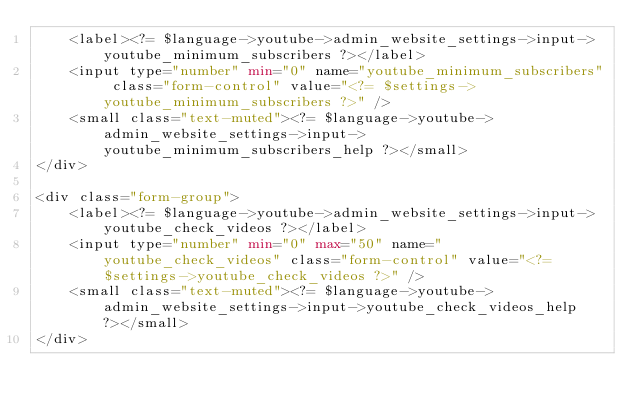<code> <loc_0><loc_0><loc_500><loc_500><_PHP_>    <label><?= $language->youtube->admin_website_settings->input->youtube_minimum_subscribers ?></label>
    <input type="number" min="0" name="youtube_minimum_subscribers" class="form-control" value="<?= $settings->youtube_minimum_subscribers ?>" />
    <small class="text-muted"><?= $language->youtube->admin_website_settings->input->youtube_minimum_subscribers_help ?></small>
</div>

<div class="form-group">
    <label><?= $language->youtube->admin_website_settings->input->youtube_check_videos ?></label>
    <input type="number" min="0" max="50" name="youtube_check_videos" class="form-control" value="<?= $settings->youtube_check_videos ?>" />
    <small class="text-muted"><?= $language->youtube->admin_website_settings->input->youtube_check_videos_help ?></small>
</div>
</code> 